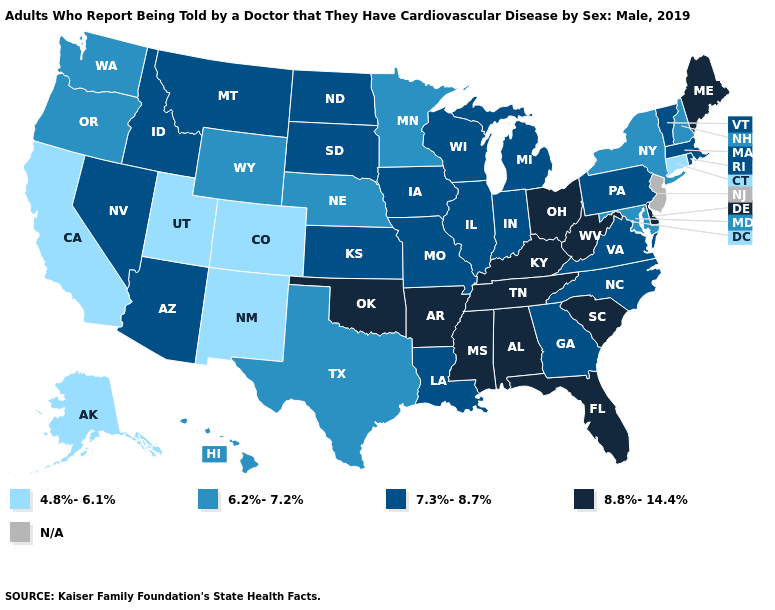Which states have the lowest value in the USA?
Keep it brief. Alaska, California, Colorado, Connecticut, New Mexico, Utah. Does Massachusetts have the lowest value in the Northeast?
Short answer required. No. Name the states that have a value in the range 8.8%-14.4%?
Give a very brief answer. Alabama, Arkansas, Delaware, Florida, Kentucky, Maine, Mississippi, Ohio, Oklahoma, South Carolina, Tennessee, West Virginia. What is the lowest value in the USA?
Short answer required. 4.8%-6.1%. Name the states that have a value in the range 4.8%-6.1%?
Keep it brief. Alaska, California, Colorado, Connecticut, New Mexico, Utah. Among the states that border Georgia , does North Carolina have the highest value?
Quick response, please. No. What is the value of Wyoming?
Answer briefly. 6.2%-7.2%. What is the value of Rhode Island?
Answer briefly. 7.3%-8.7%. Which states hav the highest value in the West?
Quick response, please. Arizona, Idaho, Montana, Nevada. What is the value of New Hampshire?
Write a very short answer. 6.2%-7.2%. Which states have the lowest value in the West?
Be succinct. Alaska, California, Colorado, New Mexico, Utah. Does Ohio have the lowest value in the MidWest?
Answer briefly. No. What is the value of Utah?
Give a very brief answer. 4.8%-6.1%. 